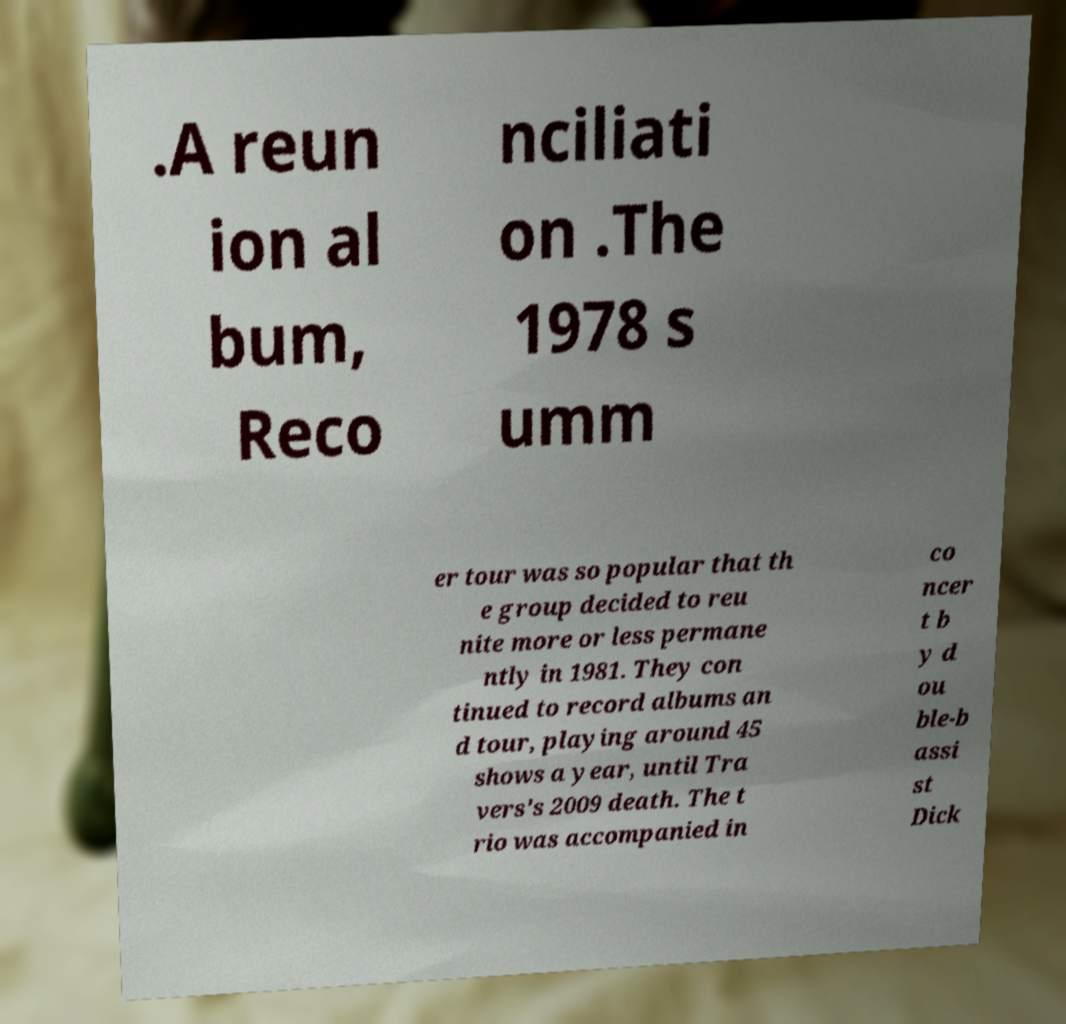Please identify and transcribe the text found in this image. .A reun ion al bum, Reco nciliati on .The 1978 s umm er tour was so popular that th e group decided to reu nite more or less permane ntly in 1981. They con tinued to record albums an d tour, playing around 45 shows a year, until Tra vers's 2009 death. The t rio was accompanied in co ncer t b y d ou ble-b assi st Dick 